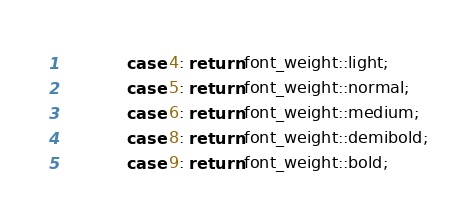Convert code to text. <code><loc_0><loc_0><loc_500><loc_500><_ObjectiveC_>            case 4: return font_weight::light;
            case 5: return font_weight::normal;
            case 6: return font_weight::medium;
            case 8: return font_weight::demibold;
            case 9: return font_weight::bold;</code> 